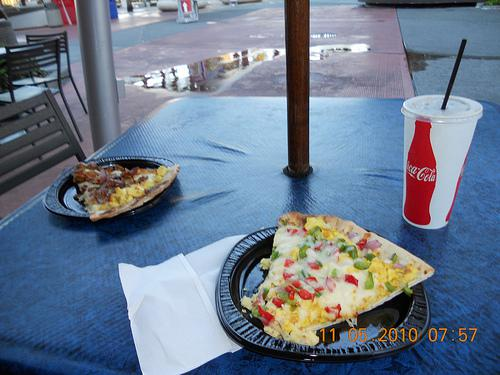Question: why is there a napkin?
Choices:
A. To clean up a mess.
B. To keep from staining shirt.
C. To wipe mouth.
D. To carry the hot plate without getting burnt.
Answer with the letter. Answer: A Question: what color is the table?
Choices:
A. Red.
B. Blue.
C. Brown.
D. White.
Answer with the letter. Answer: B Question: what food is on the plate?
Choices:
A. Pizza.
B. Steak and potato.
C. Tacos.
D. Fried seafood platter.
Answer with the letter. Answer: A Question: when was this taken?
Choices:
A. At a party.
B. During a meal.
C. In the hotel lobby.
D. At the picnic in the park.
Answer with the letter. Answer: B 